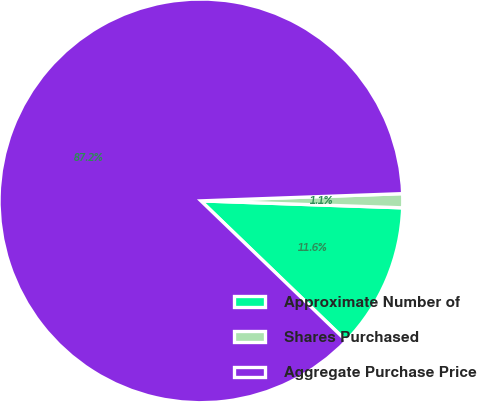Convert chart to OTSL. <chart><loc_0><loc_0><loc_500><loc_500><pie_chart><fcel>Approximate Number of<fcel>Shares Purchased<fcel>Aggregate Purchase Price<nl><fcel>11.65%<fcel>1.12%<fcel>87.23%<nl></chart> 